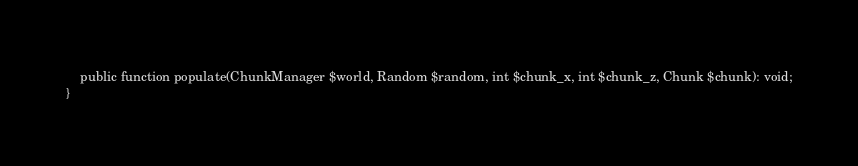Convert code to text. <code><loc_0><loc_0><loc_500><loc_500><_PHP_>
	public function populate(ChunkManager $world, Random $random, int $chunk_x, int $chunk_z, Chunk $chunk): void;
}</code> 